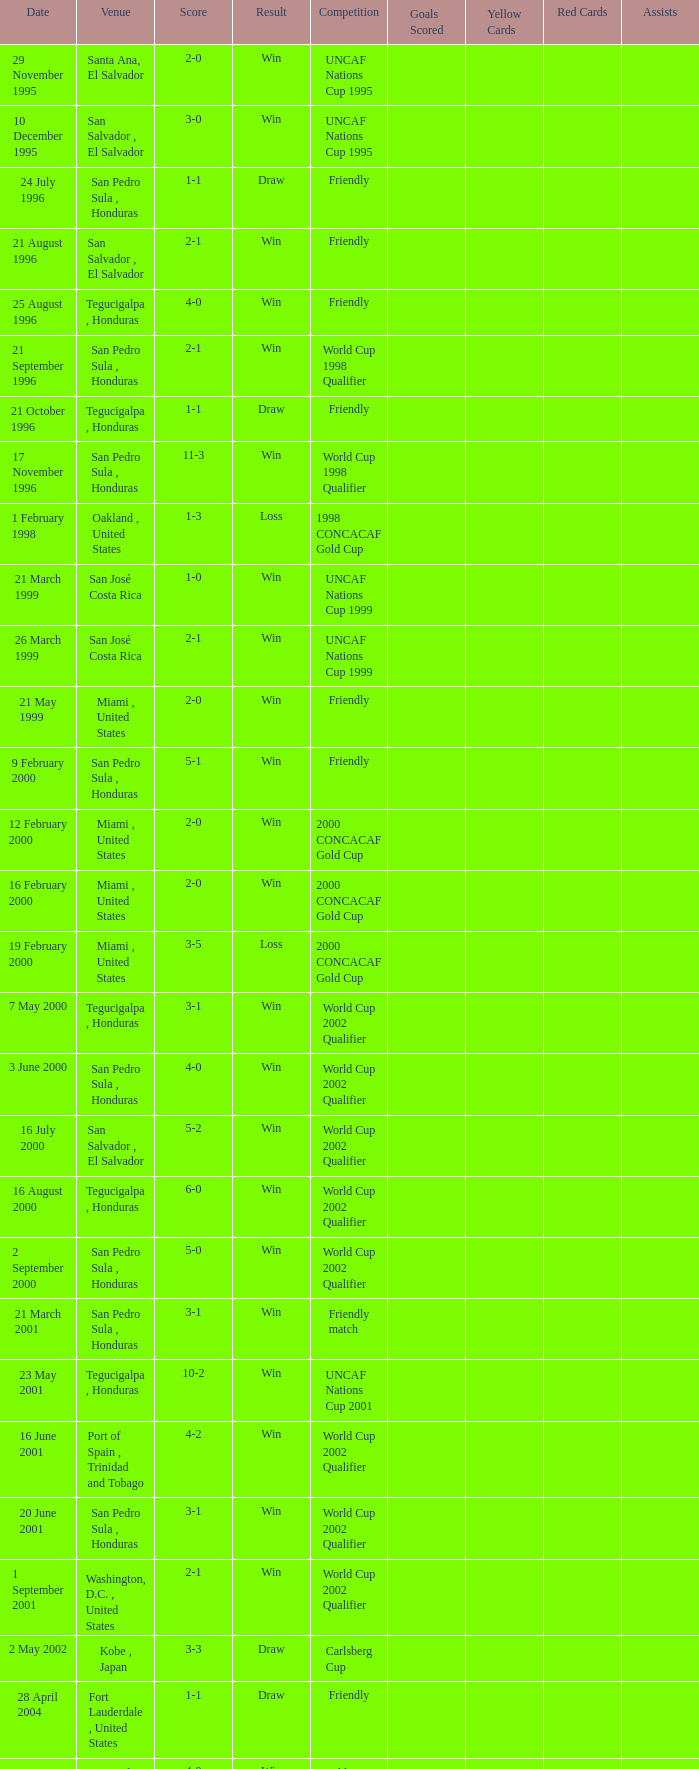Name the score for 7 may 2000 3-1. 